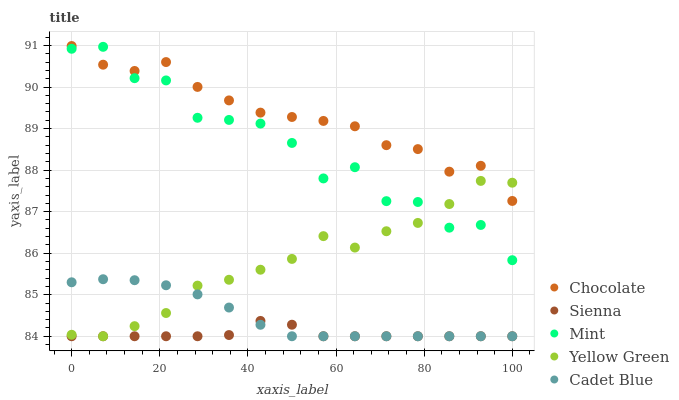Does Sienna have the minimum area under the curve?
Answer yes or no. Yes. Does Chocolate have the maximum area under the curve?
Answer yes or no. Yes. Does Cadet Blue have the minimum area under the curve?
Answer yes or no. No. Does Cadet Blue have the maximum area under the curve?
Answer yes or no. No. Is Cadet Blue the smoothest?
Answer yes or no. Yes. Is Mint the roughest?
Answer yes or no. Yes. Is Mint the smoothest?
Answer yes or no. No. Is Cadet Blue the roughest?
Answer yes or no. No. Does Sienna have the lowest value?
Answer yes or no. Yes. Does Mint have the lowest value?
Answer yes or no. No. Does Chocolate have the highest value?
Answer yes or no. Yes. Does Cadet Blue have the highest value?
Answer yes or no. No. Is Sienna less than Chocolate?
Answer yes or no. Yes. Is Chocolate greater than Cadet Blue?
Answer yes or no. Yes. Does Mint intersect Yellow Green?
Answer yes or no. Yes. Is Mint less than Yellow Green?
Answer yes or no. No. Is Mint greater than Yellow Green?
Answer yes or no. No. Does Sienna intersect Chocolate?
Answer yes or no. No. 